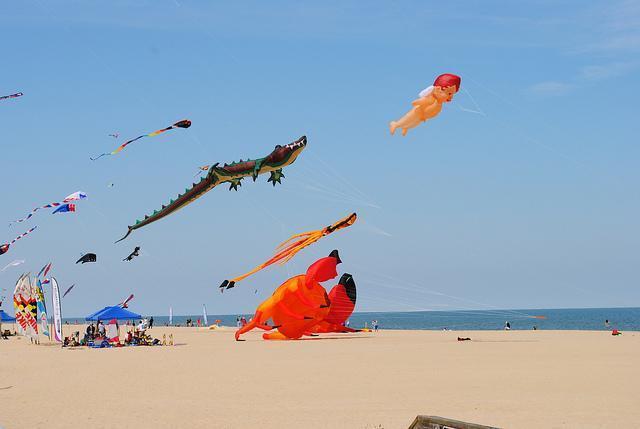How many pandas are there?
Give a very brief answer. 0. How many kites are there?
Give a very brief answer. 3. How many slices of pizza are pictured?
Give a very brief answer. 0. 